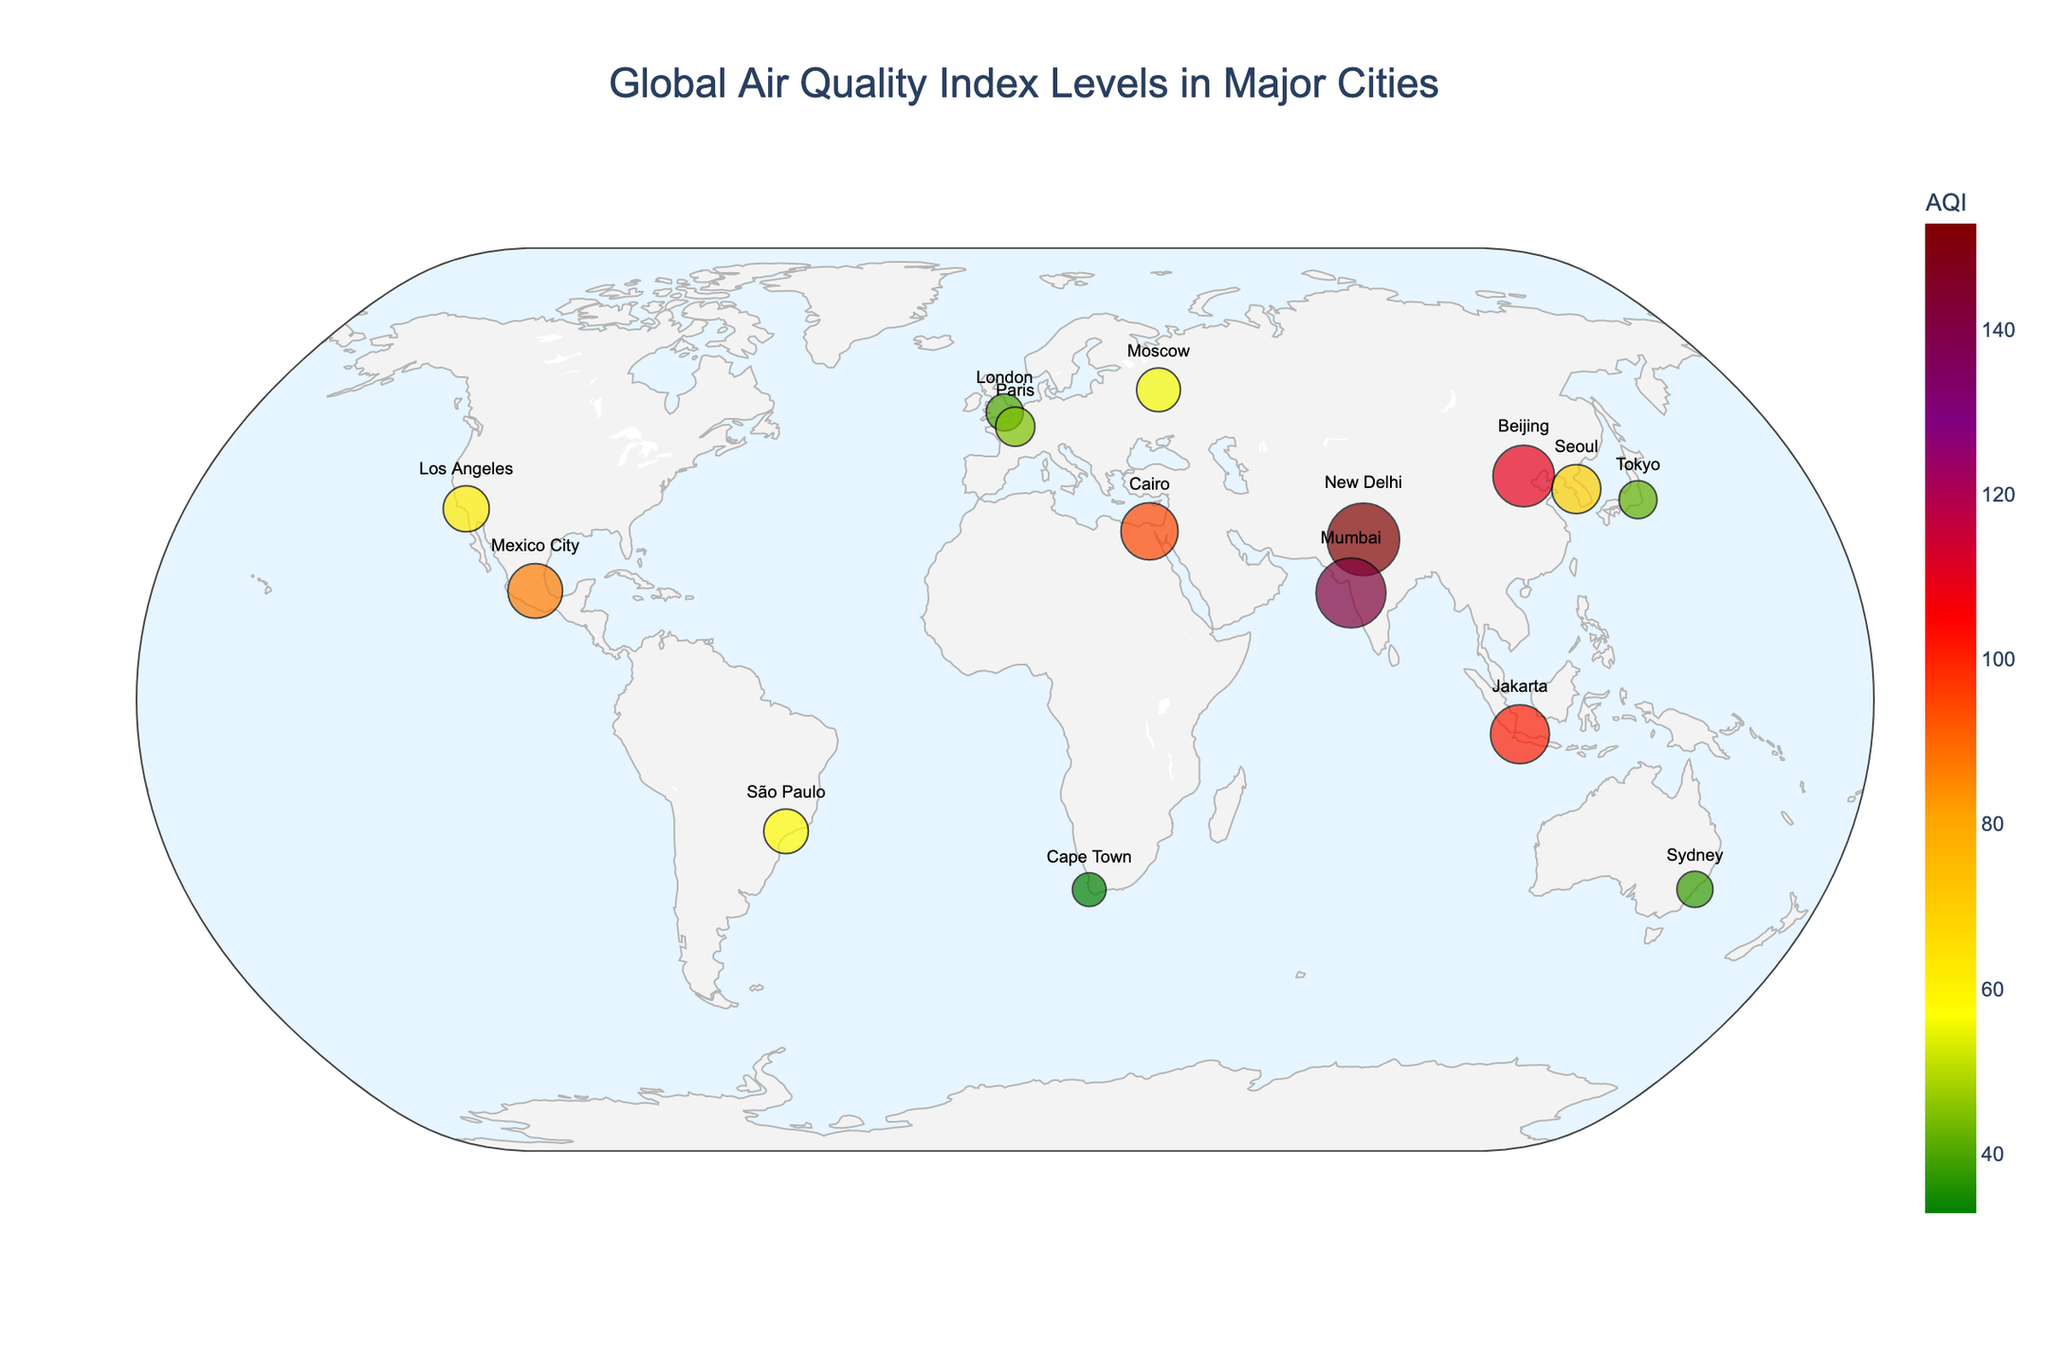What's the title of the figure? The title is placed at the top center of the figure, often in larger font to make it stand out from other text. In this case, it reads "Global Air Quality Index Levels in Major Cities".
Answer: Global Air Quality Index Levels in Major Cities Which city has the highest AQI level? By observing the size and color of each city's marker, the city with the largest and darkest marker has the highest AQI. New Delhi has the highest AQI level of 153.
Answer: New Delhi How many cities have AQI levels above 100? We need to count the number of markers that are color-coded to indicate AQI levels above 100. The cities that meet this criterion are Beijing, New Delhi, Jakarta, and Mumbai.
Answer: 4 Between Los Angeles and São Paulo, which city has a better air quality index? Los Angeles has an AQI of 62, while São Paulo has an AQI of 58. Comparing the two values, São Paulo has a slightly better AQI.
Answer: São Paulo What is the AQI range for the cities shown in the figure? To determine the range, identify the minimum and maximum AQI values among the cities. The lowest AQI is 33 (Cape Town), and the highest is 153 (New Delhi). The range is the difference between these two values, which is 153 - 33 = 120.
Answer: 120 What is the average AQI of all the cities shown in the figure? To find the average AQI, sum all the provided AQI values and divide by the number of cities. The total AQI is 110 + 153 + 62 + 40 + 95 + 87 + 101 + 56 + 45 + 70 + 58 + 42 + 38 + 33 + 142, which sums up to 1132. There are 15 cities, so the average AQI is 1132 / 15 = 75.5.
Answer: 75.5 Which city has the lowest AQI level, and what is its value? The smallest marker with the lightest color indicates the city with the lowest AQI. Cape Town has the lowest AQI level of 33.
Answer: Cape Town, 33 Compare the AQI levels between Beijing and Tokyo. Which city has a higher AQI? Beijing has an AQI level of 110 contrasted with Tokyo's AQI level of 42. Therefore, Beijing has a higher AQI.
Answer: Beijing What is the most common AQI range (color category) observed among the cities? By examining the color scale and the number of cities within each color category, most cities fall within the yellow to orange range, indicating moderate to unhealthy for sensitive groups AQI levels.
Answer: Yellow to orange Which cities have AQI levels marked in red, and what does this color indicate? Red color indicates unhealthy air quality levels. The cities marked in red are Beijing (110) and Jakarta (101).
Answer: Beijing, Jakarta 